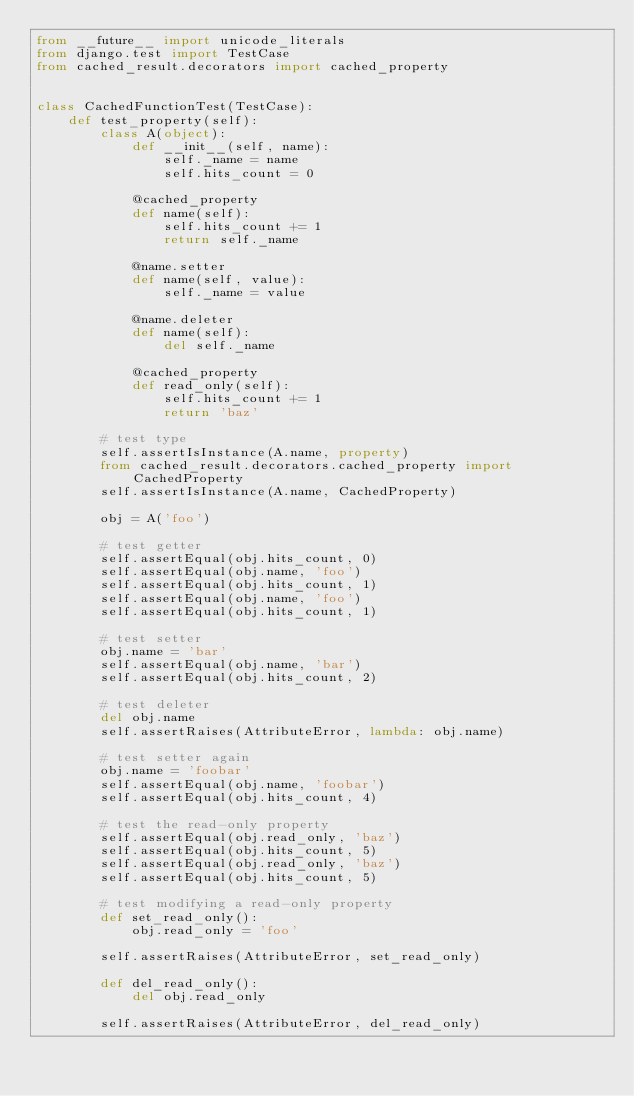<code> <loc_0><loc_0><loc_500><loc_500><_Python_>from __future__ import unicode_literals
from django.test import TestCase
from cached_result.decorators import cached_property


class CachedFunctionTest(TestCase):
    def test_property(self):
        class A(object):
            def __init__(self, name):
                self._name = name
                self.hits_count = 0

            @cached_property
            def name(self):
                self.hits_count += 1
                return self._name

            @name.setter
            def name(self, value):
                self._name = value

            @name.deleter
            def name(self):
                del self._name

            @cached_property
            def read_only(self):
                self.hits_count += 1
                return 'baz'

        # test type
        self.assertIsInstance(A.name, property)
        from cached_result.decorators.cached_property import CachedProperty
        self.assertIsInstance(A.name, CachedProperty)

        obj = A('foo')

        # test getter
        self.assertEqual(obj.hits_count, 0)
        self.assertEqual(obj.name, 'foo')
        self.assertEqual(obj.hits_count, 1)
        self.assertEqual(obj.name, 'foo')
        self.assertEqual(obj.hits_count, 1)

        # test setter
        obj.name = 'bar'
        self.assertEqual(obj.name, 'bar')
        self.assertEqual(obj.hits_count, 2)

        # test deleter
        del obj.name
        self.assertRaises(AttributeError, lambda: obj.name)

        # test setter again
        obj.name = 'foobar'
        self.assertEqual(obj.name, 'foobar')
        self.assertEqual(obj.hits_count, 4)

        # test the read-only property
        self.assertEqual(obj.read_only, 'baz')
        self.assertEqual(obj.hits_count, 5)
        self.assertEqual(obj.read_only, 'baz')
        self.assertEqual(obj.hits_count, 5)

        # test modifying a read-only property
        def set_read_only():
            obj.read_only = 'foo'

        self.assertRaises(AttributeError, set_read_only)

        def del_read_only():
            del obj.read_only

        self.assertRaises(AttributeError, del_read_only)</code> 